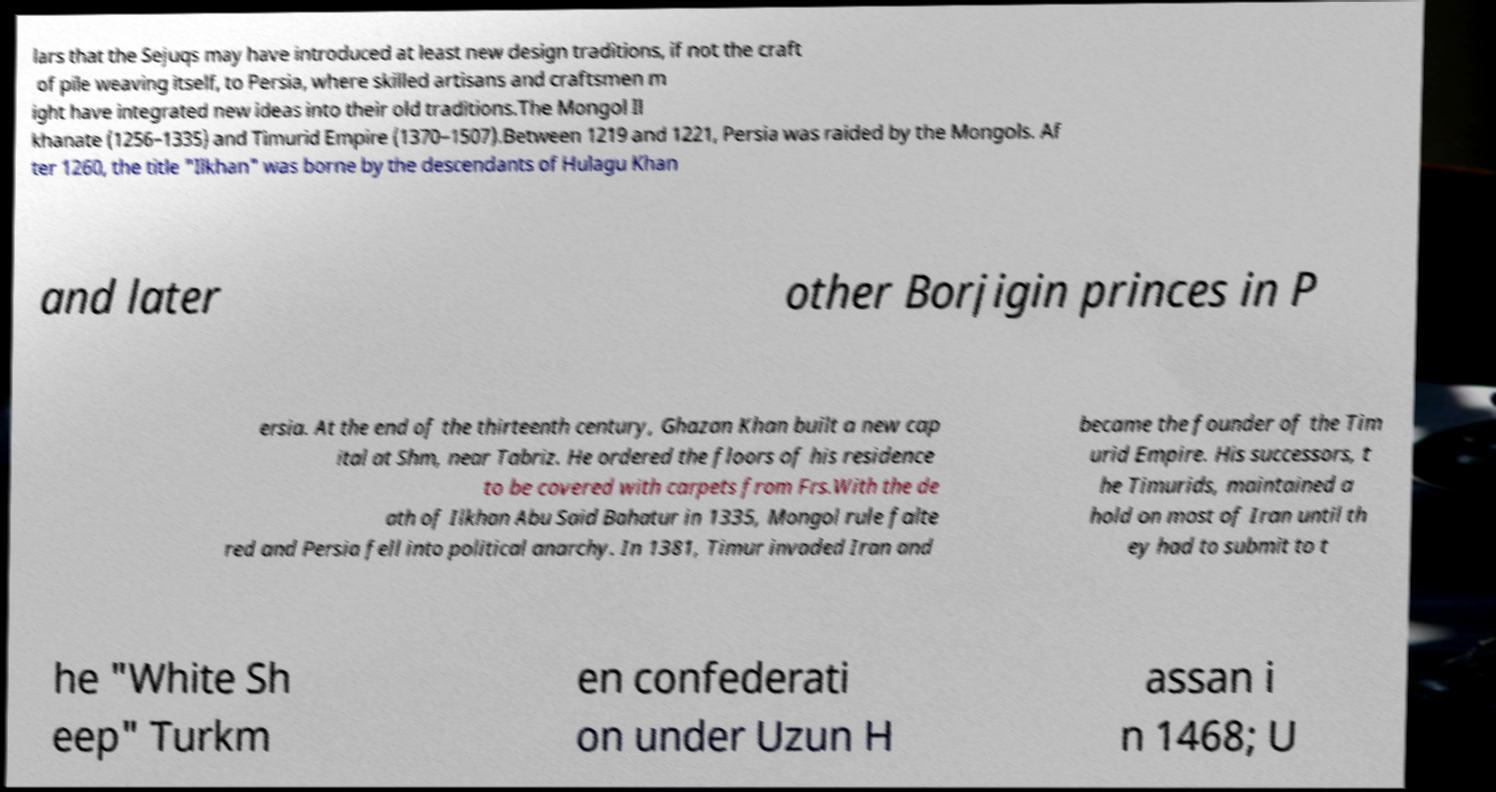There's text embedded in this image that I need extracted. Can you transcribe it verbatim? lars that the Sejuqs may have introduced at least new design traditions, if not the craft of pile weaving itself, to Persia, where skilled artisans and craftsmen m ight have integrated new ideas into their old traditions.The Mongol Il khanate (1256–1335) and Timurid Empire (1370–1507).Between 1219 and 1221, Persia was raided by the Mongols. Af ter 1260, the title "Ilkhan" was borne by the descendants of Hulagu Khan and later other Borjigin princes in P ersia. At the end of the thirteenth century, Ghazan Khan built a new cap ital at Shm, near Tabriz. He ordered the floors of his residence to be covered with carpets from Frs.With the de ath of Ilkhan Abu Said Bahatur in 1335, Mongol rule falte red and Persia fell into political anarchy. In 1381, Timur invaded Iran and became the founder of the Tim urid Empire. His successors, t he Timurids, maintained a hold on most of Iran until th ey had to submit to t he "White Sh eep" Turkm en confederati on under Uzun H assan i n 1468; U 